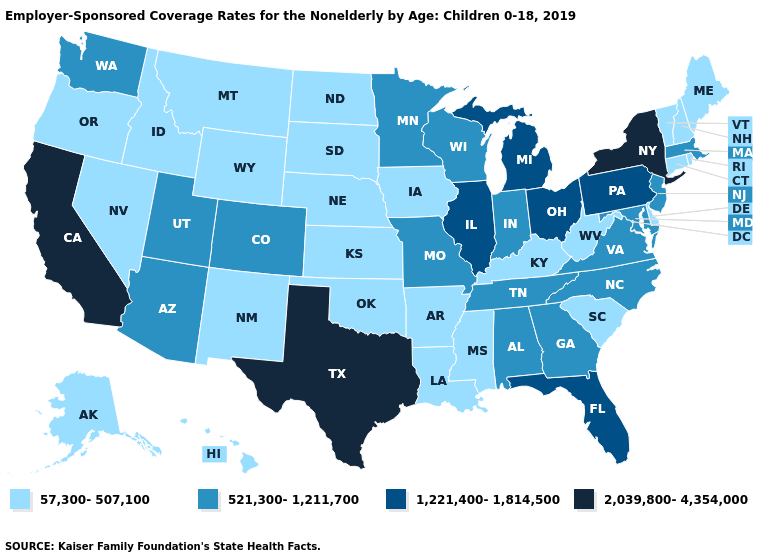Which states have the highest value in the USA?
Answer briefly. California, New York, Texas. Among the states that border Oregon , which have the lowest value?
Quick response, please. Idaho, Nevada. How many symbols are there in the legend?
Short answer required. 4. What is the value of Mississippi?
Answer briefly. 57,300-507,100. What is the value of Tennessee?
Short answer required. 521,300-1,211,700. Does Ohio have a higher value than Delaware?
Keep it brief. Yes. Which states have the highest value in the USA?
Give a very brief answer. California, New York, Texas. Which states have the lowest value in the USA?
Be succinct. Alaska, Arkansas, Connecticut, Delaware, Hawaii, Idaho, Iowa, Kansas, Kentucky, Louisiana, Maine, Mississippi, Montana, Nebraska, Nevada, New Hampshire, New Mexico, North Dakota, Oklahoma, Oregon, Rhode Island, South Carolina, South Dakota, Vermont, West Virginia, Wyoming. Name the states that have a value in the range 521,300-1,211,700?
Concise answer only. Alabama, Arizona, Colorado, Georgia, Indiana, Maryland, Massachusetts, Minnesota, Missouri, New Jersey, North Carolina, Tennessee, Utah, Virginia, Washington, Wisconsin. Does Ohio have the highest value in the MidWest?
Write a very short answer. Yes. What is the value of Tennessee?
Be succinct. 521,300-1,211,700. Does Iowa have a lower value than Washington?
Give a very brief answer. Yes. Does Utah have a higher value than Michigan?
Short answer required. No. What is the lowest value in the USA?
Quick response, please. 57,300-507,100. Name the states that have a value in the range 1,221,400-1,814,500?
Answer briefly. Florida, Illinois, Michigan, Ohio, Pennsylvania. 